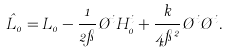<formula> <loc_0><loc_0><loc_500><loc_500>\hat { L } _ { 0 } = L _ { 0 } - \frac { 1 } { 2 \pi } \chi ^ { i } H ^ { i } _ { 0 } + \frac { k } { 4 \pi ^ { 2 } } \chi ^ { i } \chi ^ { i } .</formula> 